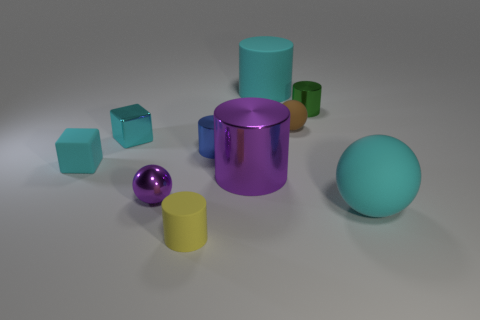There is another ball that is made of the same material as the small brown ball; what size is it?
Offer a very short reply. Large. What size is the cyan rubber object in front of the purple object that is on the left side of the tiny metal cylinder on the left side of the green cylinder?
Make the answer very short. Large. There is a cyan rubber object in front of the purple cylinder; what is its size?
Give a very brief answer. Large. What number of cyan things are either large matte things or rubber objects?
Your answer should be very brief. 3. Is there a green cylinder of the same size as the cyan shiny block?
Give a very brief answer. Yes. What material is the brown object that is the same size as the rubber cube?
Provide a succinct answer. Rubber. Does the green cylinder that is in front of the big cyan cylinder have the same size as the purple shiny thing on the right side of the yellow matte cylinder?
Your response must be concise. No. What number of things are either shiny cylinders or large matte things in front of the large purple cylinder?
Make the answer very short. 4. Is there another small green shiny thing of the same shape as the green shiny object?
Offer a terse response. No. How big is the metal thing that is right of the big purple metal thing behind the purple metal ball?
Offer a very short reply. Small. 